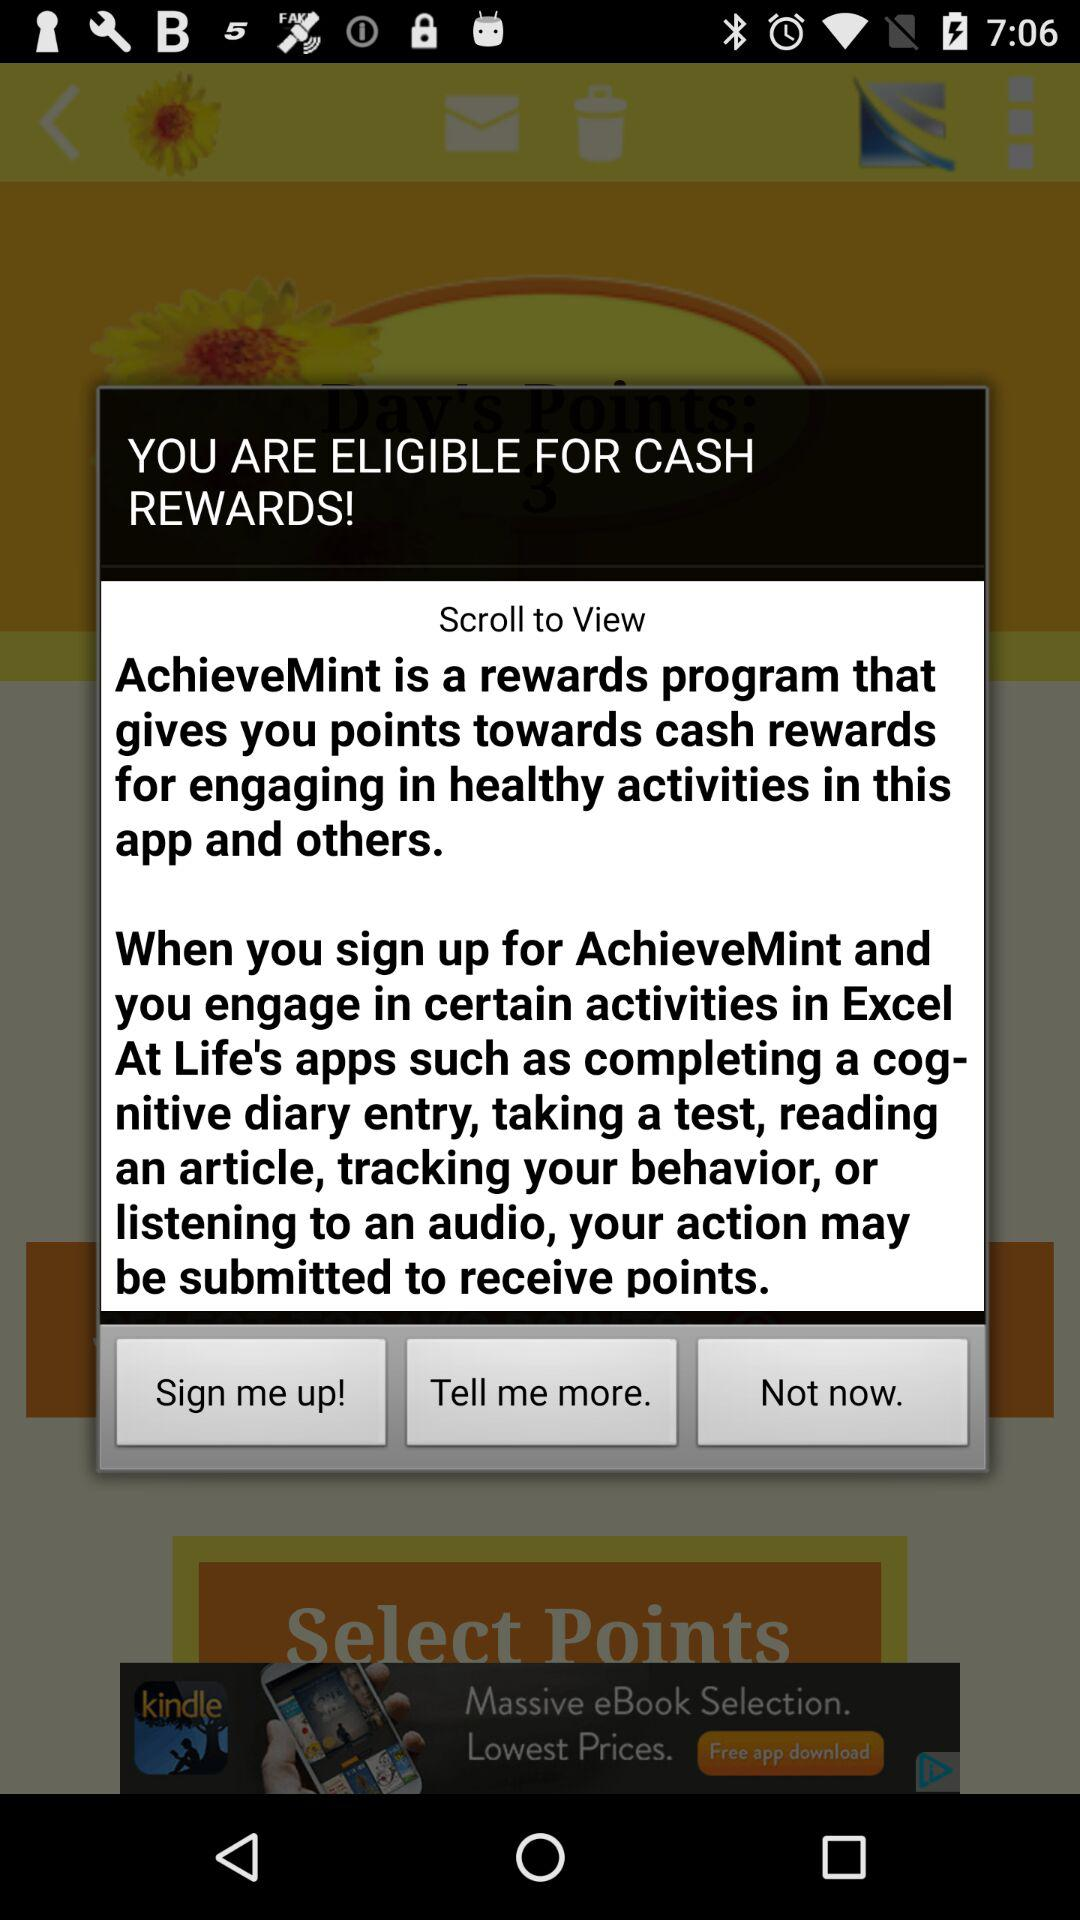What is the name of the application? The name of the application is "AchieveMint". 